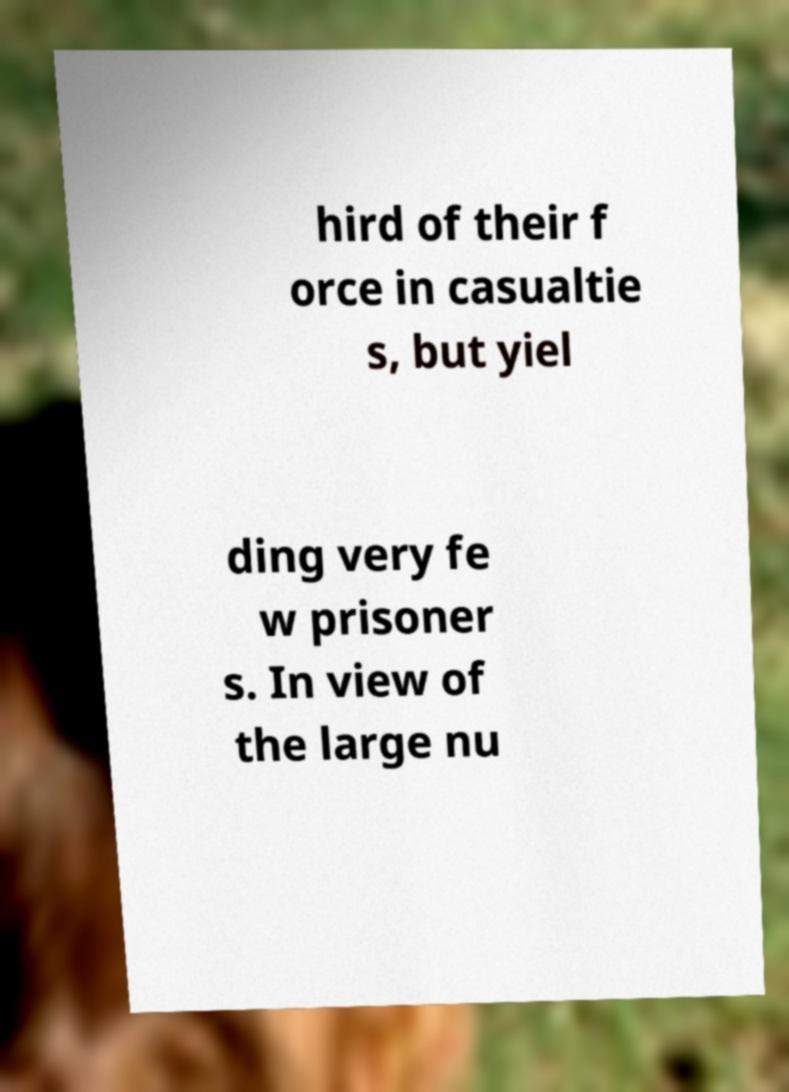There's text embedded in this image that I need extracted. Can you transcribe it verbatim? hird of their f orce in casualtie s, but yiel ding very fe w prisoner s. In view of the large nu 